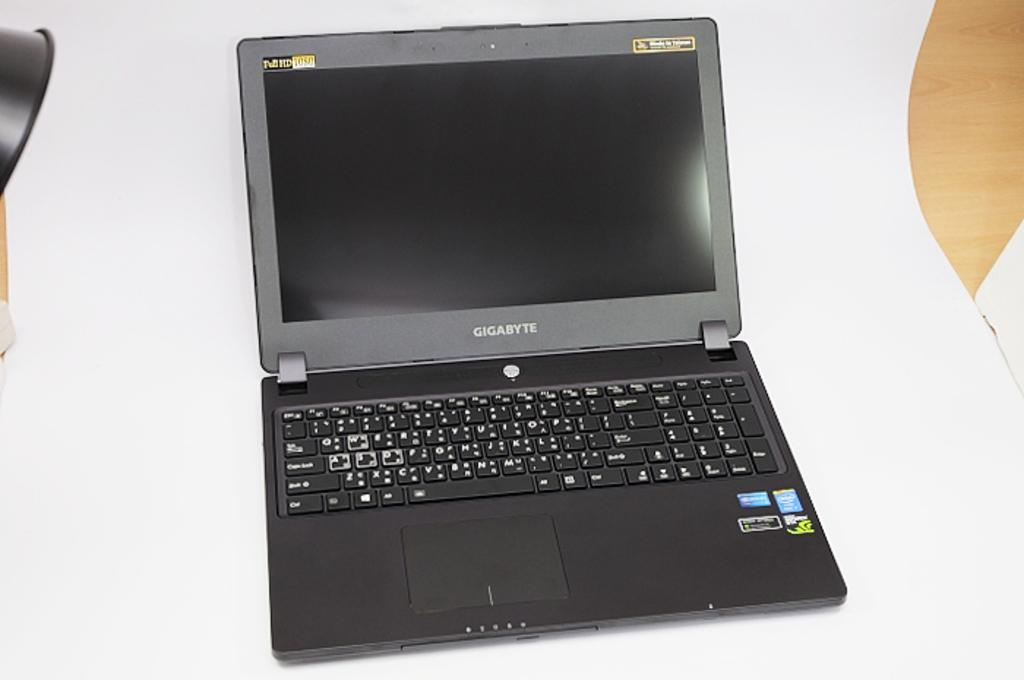<image>
Offer a succinct explanation of the picture presented. A black laptop has Gigabyte written directly below the screen. 